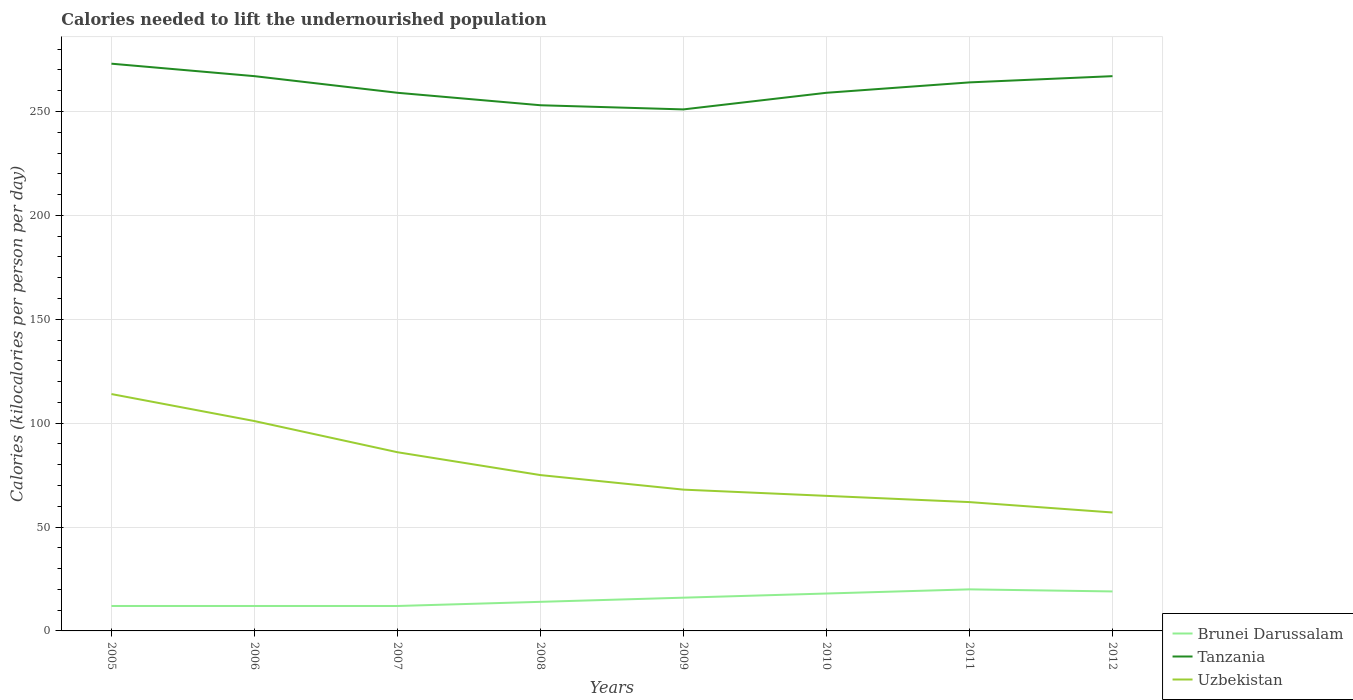How many different coloured lines are there?
Make the answer very short. 3. Across all years, what is the maximum total calories needed to lift the undernourished population in Uzbekistan?
Offer a terse response. 57. In which year was the total calories needed to lift the undernourished population in Uzbekistan maximum?
Your answer should be compact. 2012. What is the total total calories needed to lift the undernourished population in Brunei Darussalam in the graph?
Offer a terse response. -2. What is the difference between the highest and the second highest total calories needed to lift the undernourished population in Tanzania?
Provide a short and direct response. 22. What is the difference between the highest and the lowest total calories needed to lift the undernourished population in Brunei Darussalam?
Your response must be concise. 4. How many lines are there?
Your answer should be very brief. 3. How many years are there in the graph?
Give a very brief answer. 8. Does the graph contain any zero values?
Your answer should be very brief. No. Does the graph contain grids?
Your response must be concise. Yes. Where does the legend appear in the graph?
Keep it short and to the point. Bottom right. How many legend labels are there?
Your answer should be compact. 3. What is the title of the graph?
Your answer should be compact. Calories needed to lift the undernourished population. Does "South Asia" appear as one of the legend labels in the graph?
Ensure brevity in your answer.  No. What is the label or title of the Y-axis?
Give a very brief answer. Calories (kilocalories per person per day). What is the Calories (kilocalories per person per day) in Tanzania in 2005?
Your answer should be compact. 273. What is the Calories (kilocalories per person per day) of Uzbekistan in 2005?
Your response must be concise. 114. What is the Calories (kilocalories per person per day) of Brunei Darussalam in 2006?
Provide a succinct answer. 12. What is the Calories (kilocalories per person per day) of Tanzania in 2006?
Give a very brief answer. 267. What is the Calories (kilocalories per person per day) in Uzbekistan in 2006?
Give a very brief answer. 101. What is the Calories (kilocalories per person per day) in Tanzania in 2007?
Ensure brevity in your answer.  259. What is the Calories (kilocalories per person per day) of Uzbekistan in 2007?
Your answer should be very brief. 86. What is the Calories (kilocalories per person per day) of Tanzania in 2008?
Offer a very short reply. 253. What is the Calories (kilocalories per person per day) in Uzbekistan in 2008?
Give a very brief answer. 75. What is the Calories (kilocalories per person per day) of Tanzania in 2009?
Provide a short and direct response. 251. What is the Calories (kilocalories per person per day) in Uzbekistan in 2009?
Offer a terse response. 68. What is the Calories (kilocalories per person per day) of Brunei Darussalam in 2010?
Offer a terse response. 18. What is the Calories (kilocalories per person per day) in Tanzania in 2010?
Offer a very short reply. 259. What is the Calories (kilocalories per person per day) in Tanzania in 2011?
Offer a terse response. 264. What is the Calories (kilocalories per person per day) of Brunei Darussalam in 2012?
Your response must be concise. 19. What is the Calories (kilocalories per person per day) of Tanzania in 2012?
Your response must be concise. 267. What is the Calories (kilocalories per person per day) of Uzbekistan in 2012?
Your answer should be compact. 57. Across all years, what is the maximum Calories (kilocalories per person per day) of Tanzania?
Ensure brevity in your answer.  273. Across all years, what is the maximum Calories (kilocalories per person per day) of Uzbekistan?
Provide a succinct answer. 114. Across all years, what is the minimum Calories (kilocalories per person per day) of Tanzania?
Offer a very short reply. 251. Across all years, what is the minimum Calories (kilocalories per person per day) of Uzbekistan?
Your response must be concise. 57. What is the total Calories (kilocalories per person per day) in Brunei Darussalam in the graph?
Ensure brevity in your answer.  123. What is the total Calories (kilocalories per person per day) of Tanzania in the graph?
Give a very brief answer. 2093. What is the total Calories (kilocalories per person per day) of Uzbekistan in the graph?
Provide a succinct answer. 628. What is the difference between the Calories (kilocalories per person per day) of Brunei Darussalam in 2005 and that in 2006?
Keep it short and to the point. 0. What is the difference between the Calories (kilocalories per person per day) of Uzbekistan in 2005 and that in 2006?
Keep it short and to the point. 13. What is the difference between the Calories (kilocalories per person per day) in Tanzania in 2005 and that in 2007?
Provide a short and direct response. 14. What is the difference between the Calories (kilocalories per person per day) in Tanzania in 2005 and that in 2008?
Keep it short and to the point. 20. What is the difference between the Calories (kilocalories per person per day) of Uzbekistan in 2005 and that in 2008?
Offer a very short reply. 39. What is the difference between the Calories (kilocalories per person per day) of Tanzania in 2005 and that in 2009?
Offer a very short reply. 22. What is the difference between the Calories (kilocalories per person per day) in Uzbekistan in 2005 and that in 2009?
Ensure brevity in your answer.  46. What is the difference between the Calories (kilocalories per person per day) of Brunei Darussalam in 2005 and that in 2010?
Give a very brief answer. -6. What is the difference between the Calories (kilocalories per person per day) of Tanzania in 2005 and that in 2010?
Ensure brevity in your answer.  14. What is the difference between the Calories (kilocalories per person per day) in Tanzania in 2005 and that in 2011?
Make the answer very short. 9. What is the difference between the Calories (kilocalories per person per day) in Uzbekistan in 2005 and that in 2011?
Keep it short and to the point. 52. What is the difference between the Calories (kilocalories per person per day) of Brunei Darussalam in 2006 and that in 2007?
Your response must be concise. 0. What is the difference between the Calories (kilocalories per person per day) of Brunei Darussalam in 2006 and that in 2008?
Provide a succinct answer. -2. What is the difference between the Calories (kilocalories per person per day) in Uzbekistan in 2006 and that in 2008?
Your response must be concise. 26. What is the difference between the Calories (kilocalories per person per day) in Brunei Darussalam in 2006 and that in 2009?
Ensure brevity in your answer.  -4. What is the difference between the Calories (kilocalories per person per day) in Uzbekistan in 2006 and that in 2009?
Provide a short and direct response. 33. What is the difference between the Calories (kilocalories per person per day) of Tanzania in 2006 and that in 2010?
Offer a terse response. 8. What is the difference between the Calories (kilocalories per person per day) in Uzbekistan in 2006 and that in 2010?
Give a very brief answer. 36. What is the difference between the Calories (kilocalories per person per day) of Brunei Darussalam in 2006 and that in 2011?
Your answer should be compact. -8. What is the difference between the Calories (kilocalories per person per day) in Tanzania in 2006 and that in 2011?
Give a very brief answer. 3. What is the difference between the Calories (kilocalories per person per day) of Tanzania in 2006 and that in 2012?
Your response must be concise. 0. What is the difference between the Calories (kilocalories per person per day) in Brunei Darussalam in 2007 and that in 2008?
Offer a very short reply. -2. What is the difference between the Calories (kilocalories per person per day) in Tanzania in 2007 and that in 2008?
Your response must be concise. 6. What is the difference between the Calories (kilocalories per person per day) of Uzbekistan in 2007 and that in 2008?
Your answer should be very brief. 11. What is the difference between the Calories (kilocalories per person per day) of Brunei Darussalam in 2007 and that in 2009?
Offer a very short reply. -4. What is the difference between the Calories (kilocalories per person per day) in Brunei Darussalam in 2007 and that in 2010?
Give a very brief answer. -6. What is the difference between the Calories (kilocalories per person per day) in Tanzania in 2007 and that in 2010?
Make the answer very short. 0. What is the difference between the Calories (kilocalories per person per day) in Brunei Darussalam in 2007 and that in 2011?
Make the answer very short. -8. What is the difference between the Calories (kilocalories per person per day) in Uzbekistan in 2007 and that in 2011?
Provide a short and direct response. 24. What is the difference between the Calories (kilocalories per person per day) of Tanzania in 2007 and that in 2012?
Offer a very short reply. -8. What is the difference between the Calories (kilocalories per person per day) in Uzbekistan in 2007 and that in 2012?
Offer a very short reply. 29. What is the difference between the Calories (kilocalories per person per day) of Brunei Darussalam in 2008 and that in 2009?
Your response must be concise. -2. What is the difference between the Calories (kilocalories per person per day) in Brunei Darussalam in 2008 and that in 2010?
Ensure brevity in your answer.  -4. What is the difference between the Calories (kilocalories per person per day) in Uzbekistan in 2008 and that in 2011?
Give a very brief answer. 13. What is the difference between the Calories (kilocalories per person per day) in Brunei Darussalam in 2008 and that in 2012?
Your answer should be very brief. -5. What is the difference between the Calories (kilocalories per person per day) in Uzbekistan in 2008 and that in 2012?
Provide a succinct answer. 18. What is the difference between the Calories (kilocalories per person per day) of Brunei Darussalam in 2009 and that in 2011?
Give a very brief answer. -4. What is the difference between the Calories (kilocalories per person per day) of Tanzania in 2009 and that in 2011?
Provide a short and direct response. -13. What is the difference between the Calories (kilocalories per person per day) in Uzbekistan in 2009 and that in 2011?
Ensure brevity in your answer.  6. What is the difference between the Calories (kilocalories per person per day) in Tanzania in 2009 and that in 2012?
Keep it short and to the point. -16. What is the difference between the Calories (kilocalories per person per day) in Uzbekistan in 2009 and that in 2012?
Make the answer very short. 11. What is the difference between the Calories (kilocalories per person per day) in Tanzania in 2010 and that in 2011?
Your answer should be very brief. -5. What is the difference between the Calories (kilocalories per person per day) of Brunei Darussalam in 2010 and that in 2012?
Ensure brevity in your answer.  -1. What is the difference between the Calories (kilocalories per person per day) in Tanzania in 2010 and that in 2012?
Your response must be concise. -8. What is the difference between the Calories (kilocalories per person per day) in Uzbekistan in 2010 and that in 2012?
Keep it short and to the point. 8. What is the difference between the Calories (kilocalories per person per day) of Tanzania in 2011 and that in 2012?
Your response must be concise. -3. What is the difference between the Calories (kilocalories per person per day) of Brunei Darussalam in 2005 and the Calories (kilocalories per person per day) of Tanzania in 2006?
Keep it short and to the point. -255. What is the difference between the Calories (kilocalories per person per day) in Brunei Darussalam in 2005 and the Calories (kilocalories per person per day) in Uzbekistan in 2006?
Keep it short and to the point. -89. What is the difference between the Calories (kilocalories per person per day) of Tanzania in 2005 and the Calories (kilocalories per person per day) of Uzbekistan in 2006?
Your response must be concise. 172. What is the difference between the Calories (kilocalories per person per day) of Brunei Darussalam in 2005 and the Calories (kilocalories per person per day) of Tanzania in 2007?
Your response must be concise. -247. What is the difference between the Calories (kilocalories per person per day) in Brunei Darussalam in 2005 and the Calories (kilocalories per person per day) in Uzbekistan in 2007?
Provide a succinct answer. -74. What is the difference between the Calories (kilocalories per person per day) of Tanzania in 2005 and the Calories (kilocalories per person per day) of Uzbekistan in 2007?
Your answer should be very brief. 187. What is the difference between the Calories (kilocalories per person per day) of Brunei Darussalam in 2005 and the Calories (kilocalories per person per day) of Tanzania in 2008?
Your answer should be very brief. -241. What is the difference between the Calories (kilocalories per person per day) of Brunei Darussalam in 2005 and the Calories (kilocalories per person per day) of Uzbekistan in 2008?
Give a very brief answer. -63. What is the difference between the Calories (kilocalories per person per day) in Tanzania in 2005 and the Calories (kilocalories per person per day) in Uzbekistan in 2008?
Offer a terse response. 198. What is the difference between the Calories (kilocalories per person per day) in Brunei Darussalam in 2005 and the Calories (kilocalories per person per day) in Tanzania in 2009?
Make the answer very short. -239. What is the difference between the Calories (kilocalories per person per day) in Brunei Darussalam in 2005 and the Calories (kilocalories per person per day) in Uzbekistan in 2009?
Offer a terse response. -56. What is the difference between the Calories (kilocalories per person per day) in Tanzania in 2005 and the Calories (kilocalories per person per day) in Uzbekistan in 2009?
Provide a succinct answer. 205. What is the difference between the Calories (kilocalories per person per day) of Brunei Darussalam in 2005 and the Calories (kilocalories per person per day) of Tanzania in 2010?
Offer a terse response. -247. What is the difference between the Calories (kilocalories per person per day) in Brunei Darussalam in 2005 and the Calories (kilocalories per person per day) in Uzbekistan in 2010?
Offer a terse response. -53. What is the difference between the Calories (kilocalories per person per day) of Tanzania in 2005 and the Calories (kilocalories per person per day) of Uzbekistan in 2010?
Provide a succinct answer. 208. What is the difference between the Calories (kilocalories per person per day) in Brunei Darussalam in 2005 and the Calories (kilocalories per person per day) in Tanzania in 2011?
Your response must be concise. -252. What is the difference between the Calories (kilocalories per person per day) of Brunei Darussalam in 2005 and the Calories (kilocalories per person per day) of Uzbekistan in 2011?
Make the answer very short. -50. What is the difference between the Calories (kilocalories per person per day) in Tanzania in 2005 and the Calories (kilocalories per person per day) in Uzbekistan in 2011?
Your answer should be very brief. 211. What is the difference between the Calories (kilocalories per person per day) in Brunei Darussalam in 2005 and the Calories (kilocalories per person per day) in Tanzania in 2012?
Provide a short and direct response. -255. What is the difference between the Calories (kilocalories per person per day) in Brunei Darussalam in 2005 and the Calories (kilocalories per person per day) in Uzbekistan in 2012?
Ensure brevity in your answer.  -45. What is the difference between the Calories (kilocalories per person per day) in Tanzania in 2005 and the Calories (kilocalories per person per day) in Uzbekistan in 2012?
Make the answer very short. 216. What is the difference between the Calories (kilocalories per person per day) of Brunei Darussalam in 2006 and the Calories (kilocalories per person per day) of Tanzania in 2007?
Make the answer very short. -247. What is the difference between the Calories (kilocalories per person per day) in Brunei Darussalam in 2006 and the Calories (kilocalories per person per day) in Uzbekistan in 2007?
Your response must be concise. -74. What is the difference between the Calories (kilocalories per person per day) of Tanzania in 2006 and the Calories (kilocalories per person per day) of Uzbekistan in 2007?
Keep it short and to the point. 181. What is the difference between the Calories (kilocalories per person per day) in Brunei Darussalam in 2006 and the Calories (kilocalories per person per day) in Tanzania in 2008?
Your response must be concise. -241. What is the difference between the Calories (kilocalories per person per day) of Brunei Darussalam in 2006 and the Calories (kilocalories per person per day) of Uzbekistan in 2008?
Your response must be concise. -63. What is the difference between the Calories (kilocalories per person per day) in Tanzania in 2006 and the Calories (kilocalories per person per day) in Uzbekistan in 2008?
Provide a succinct answer. 192. What is the difference between the Calories (kilocalories per person per day) in Brunei Darussalam in 2006 and the Calories (kilocalories per person per day) in Tanzania in 2009?
Provide a short and direct response. -239. What is the difference between the Calories (kilocalories per person per day) in Brunei Darussalam in 2006 and the Calories (kilocalories per person per day) in Uzbekistan in 2009?
Offer a very short reply. -56. What is the difference between the Calories (kilocalories per person per day) of Tanzania in 2006 and the Calories (kilocalories per person per day) of Uzbekistan in 2009?
Your answer should be compact. 199. What is the difference between the Calories (kilocalories per person per day) of Brunei Darussalam in 2006 and the Calories (kilocalories per person per day) of Tanzania in 2010?
Your response must be concise. -247. What is the difference between the Calories (kilocalories per person per day) of Brunei Darussalam in 2006 and the Calories (kilocalories per person per day) of Uzbekistan in 2010?
Your answer should be compact. -53. What is the difference between the Calories (kilocalories per person per day) of Tanzania in 2006 and the Calories (kilocalories per person per day) of Uzbekistan in 2010?
Your answer should be compact. 202. What is the difference between the Calories (kilocalories per person per day) of Brunei Darussalam in 2006 and the Calories (kilocalories per person per day) of Tanzania in 2011?
Offer a very short reply. -252. What is the difference between the Calories (kilocalories per person per day) of Brunei Darussalam in 2006 and the Calories (kilocalories per person per day) of Uzbekistan in 2011?
Give a very brief answer. -50. What is the difference between the Calories (kilocalories per person per day) of Tanzania in 2006 and the Calories (kilocalories per person per day) of Uzbekistan in 2011?
Offer a very short reply. 205. What is the difference between the Calories (kilocalories per person per day) in Brunei Darussalam in 2006 and the Calories (kilocalories per person per day) in Tanzania in 2012?
Provide a short and direct response. -255. What is the difference between the Calories (kilocalories per person per day) of Brunei Darussalam in 2006 and the Calories (kilocalories per person per day) of Uzbekistan in 2012?
Make the answer very short. -45. What is the difference between the Calories (kilocalories per person per day) of Tanzania in 2006 and the Calories (kilocalories per person per day) of Uzbekistan in 2012?
Give a very brief answer. 210. What is the difference between the Calories (kilocalories per person per day) in Brunei Darussalam in 2007 and the Calories (kilocalories per person per day) in Tanzania in 2008?
Your response must be concise. -241. What is the difference between the Calories (kilocalories per person per day) in Brunei Darussalam in 2007 and the Calories (kilocalories per person per day) in Uzbekistan in 2008?
Your response must be concise. -63. What is the difference between the Calories (kilocalories per person per day) of Tanzania in 2007 and the Calories (kilocalories per person per day) of Uzbekistan in 2008?
Offer a very short reply. 184. What is the difference between the Calories (kilocalories per person per day) in Brunei Darussalam in 2007 and the Calories (kilocalories per person per day) in Tanzania in 2009?
Provide a short and direct response. -239. What is the difference between the Calories (kilocalories per person per day) of Brunei Darussalam in 2007 and the Calories (kilocalories per person per day) of Uzbekistan in 2009?
Your response must be concise. -56. What is the difference between the Calories (kilocalories per person per day) in Tanzania in 2007 and the Calories (kilocalories per person per day) in Uzbekistan in 2009?
Ensure brevity in your answer.  191. What is the difference between the Calories (kilocalories per person per day) of Brunei Darussalam in 2007 and the Calories (kilocalories per person per day) of Tanzania in 2010?
Offer a very short reply. -247. What is the difference between the Calories (kilocalories per person per day) of Brunei Darussalam in 2007 and the Calories (kilocalories per person per day) of Uzbekistan in 2010?
Your answer should be very brief. -53. What is the difference between the Calories (kilocalories per person per day) in Tanzania in 2007 and the Calories (kilocalories per person per day) in Uzbekistan in 2010?
Your answer should be compact. 194. What is the difference between the Calories (kilocalories per person per day) in Brunei Darussalam in 2007 and the Calories (kilocalories per person per day) in Tanzania in 2011?
Make the answer very short. -252. What is the difference between the Calories (kilocalories per person per day) of Brunei Darussalam in 2007 and the Calories (kilocalories per person per day) of Uzbekistan in 2011?
Give a very brief answer. -50. What is the difference between the Calories (kilocalories per person per day) of Tanzania in 2007 and the Calories (kilocalories per person per day) of Uzbekistan in 2011?
Offer a terse response. 197. What is the difference between the Calories (kilocalories per person per day) in Brunei Darussalam in 2007 and the Calories (kilocalories per person per day) in Tanzania in 2012?
Your answer should be very brief. -255. What is the difference between the Calories (kilocalories per person per day) of Brunei Darussalam in 2007 and the Calories (kilocalories per person per day) of Uzbekistan in 2012?
Your answer should be compact. -45. What is the difference between the Calories (kilocalories per person per day) of Tanzania in 2007 and the Calories (kilocalories per person per day) of Uzbekistan in 2012?
Provide a succinct answer. 202. What is the difference between the Calories (kilocalories per person per day) of Brunei Darussalam in 2008 and the Calories (kilocalories per person per day) of Tanzania in 2009?
Keep it short and to the point. -237. What is the difference between the Calories (kilocalories per person per day) of Brunei Darussalam in 2008 and the Calories (kilocalories per person per day) of Uzbekistan in 2009?
Make the answer very short. -54. What is the difference between the Calories (kilocalories per person per day) in Tanzania in 2008 and the Calories (kilocalories per person per day) in Uzbekistan in 2009?
Offer a very short reply. 185. What is the difference between the Calories (kilocalories per person per day) in Brunei Darussalam in 2008 and the Calories (kilocalories per person per day) in Tanzania in 2010?
Keep it short and to the point. -245. What is the difference between the Calories (kilocalories per person per day) of Brunei Darussalam in 2008 and the Calories (kilocalories per person per day) of Uzbekistan in 2010?
Provide a succinct answer. -51. What is the difference between the Calories (kilocalories per person per day) of Tanzania in 2008 and the Calories (kilocalories per person per day) of Uzbekistan in 2010?
Make the answer very short. 188. What is the difference between the Calories (kilocalories per person per day) of Brunei Darussalam in 2008 and the Calories (kilocalories per person per day) of Tanzania in 2011?
Provide a succinct answer. -250. What is the difference between the Calories (kilocalories per person per day) in Brunei Darussalam in 2008 and the Calories (kilocalories per person per day) in Uzbekistan in 2011?
Give a very brief answer. -48. What is the difference between the Calories (kilocalories per person per day) of Tanzania in 2008 and the Calories (kilocalories per person per day) of Uzbekistan in 2011?
Give a very brief answer. 191. What is the difference between the Calories (kilocalories per person per day) of Brunei Darussalam in 2008 and the Calories (kilocalories per person per day) of Tanzania in 2012?
Keep it short and to the point. -253. What is the difference between the Calories (kilocalories per person per day) in Brunei Darussalam in 2008 and the Calories (kilocalories per person per day) in Uzbekistan in 2012?
Your answer should be compact. -43. What is the difference between the Calories (kilocalories per person per day) of Tanzania in 2008 and the Calories (kilocalories per person per day) of Uzbekistan in 2012?
Provide a succinct answer. 196. What is the difference between the Calories (kilocalories per person per day) of Brunei Darussalam in 2009 and the Calories (kilocalories per person per day) of Tanzania in 2010?
Provide a succinct answer. -243. What is the difference between the Calories (kilocalories per person per day) in Brunei Darussalam in 2009 and the Calories (kilocalories per person per day) in Uzbekistan in 2010?
Offer a very short reply. -49. What is the difference between the Calories (kilocalories per person per day) in Tanzania in 2009 and the Calories (kilocalories per person per day) in Uzbekistan in 2010?
Provide a succinct answer. 186. What is the difference between the Calories (kilocalories per person per day) of Brunei Darussalam in 2009 and the Calories (kilocalories per person per day) of Tanzania in 2011?
Provide a succinct answer. -248. What is the difference between the Calories (kilocalories per person per day) in Brunei Darussalam in 2009 and the Calories (kilocalories per person per day) in Uzbekistan in 2011?
Offer a terse response. -46. What is the difference between the Calories (kilocalories per person per day) of Tanzania in 2009 and the Calories (kilocalories per person per day) of Uzbekistan in 2011?
Give a very brief answer. 189. What is the difference between the Calories (kilocalories per person per day) of Brunei Darussalam in 2009 and the Calories (kilocalories per person per day) of Tanzania in 2012?
Make the answer very short. -251. What is the difference between the Calories (kilocalories per person per day) of Brunei Darussalam in 2009 and the Calories (kilocalories per person per day) of Uzbekistan in 2012?
Offer a very short reply. -41. What is the difference between the Calories (kilocalories per person per day) of Tanzania in 2009 and the Calories (kilocalories per person per day) of Uzbekistan in 2012?
Keep it short and to the point. 194. What is the difference between the Calories (kilocalories per person per day) of Brunei Darussalam in 2010 and the Calories (kilocalories per person per day) of Tanzania in 2011?
Your answer should be compact. -246. What is the difference between the Calories (kilocalories per person per day) in Brunei Darussalam in 2010 and the Calories (kilocalories per person per day) in Uzbekistan in 2011?
Offer a very short reply. -44. What is the difference between the Calories (kilocalories per person per day) of Tanzania in 2010 and the Calories (kilocalories per person per day) of Uzbekistan in 2011?
Provide a short and direct response. 197. What is the difference between the Calories (kilocalories per person per day) in Brunei Darussalam in 2010 and the Calories (kilocalories per person per day) in Tanzania in 2012?
Make the answer very short. -249. What is the difference between the Calories (kilocalories per person per day) of Brunei Darussalam in 2010 and the Calories (kilocalories per person per day) of Uzbekistan in 2012?
Provide a short and direct response. -39. What is the difference between the Calories (kilocalories per person per day) in Tanzania in 2010 and the Calories (kilocalories per person per day) in Uzbekistan in 2012?
Your answer should be very brief. 202. What is the difference between the Calories (kilocalories per person per day) in Brunei Darussalam in 2011 and the Calories (kilocalories per person per day) in Tanzania in 2012?
Your response must be concise. -247. What is the difference between the Calories (kilocalories per person per day) in Brunei Darussalam in 2011 and the Calories (kilocalories per person per day) in Uzbekistan in 2012?
Make the answer very short. -37. What is the difference between the Calories (kilocalories per person per day) in Tanzania in 2011 and the Calories (kilocalories per person per day) in Uzbekistan in 2012?
Your answer should be compact. 207. What is the average Calories (kilocalories per person per day) in Brunei Darussalam per year?
Provide a short and direct response. 15.38. What is the average Calories (kilocalories per person per day) in Tanzania per year?
Offer a very short reply. 261.62. What is the average Calories (kilocalories per person per day) in Uzbekistan per year?
Your answer should be very brief. 78.5. In the year 2005, what is the difference between the Calories (kilocalories per person per day) in Brunei Darussalam and Calories (kilocalories per person per day) in Tanzania?
Give a very brief answer. -261. In the year 2005, what is the difference between the Calories (kilocalories per person per day) in Brunei Darussalam and Calories (kilocalories per person per day) in Uzbekistan?
Provide a succinct answer. -102. In the year 2005, what is the difference between the Calories (kilocalories per person per day) of Tanzania and Calories (kilocalories per person per day) of Uzbekistan?
Your response must be concise. 159. In the year 2006, what is the difference between the Calories (kilocalories per person per day) of Brunei Darussalam and Calories (kilocalories per person per day) of Tanzania?
Keep it short and to the point. -255. In the year 2006, what is the difference between the Calories (kilocalories per person per day) of Brunei Darussalam and Calories (kilocalories per person per day) of Uzbekistan?
Ensure brevity in your answer.  -89. In the year 2006, what is the difference between the Calories (kilocalories per person per day) in Tanzania and Calories (kilocalories per person per day) in Uzbekistan?
Provide a succinct answer. 166. In the year 2007, what is the difference between the Calories (kilocalories per person per day) in Brunei Darussalam and Calories (kilocalories per person per day) in Tanzania?
Make the answer very short. -247. In the year 2007, what is the difference between the Calories (kilocalories per person per day) in Brunei Darussalam and Calories (kilocalories per person per day) in Uzbekistan?
Make the answer very short. -74. In the year 2007, what is the difference between the Calories (kilocalories per person per day) in Tanzania and Calories (kilocalories per person per day) in Uzbekistan?
Your answer should be very brief. 173. In the year 2008, what is the difference between the Calories (kilocalories per person per day) of Brunei Darussalam and Calories (kilocalories per person per day) of Tanzania?
Give a very brief answer. -239. In the year 2008, what is the difference between the Calories (kilocalories per person per day) in Brunei Darussalam and Calories (kilocalories per person per day) in Uzbekistan?
Provide a succinct answer. -61. In the year 2008, what is the difference between the Calories (kilocalories per person per day) in Tanzania and Calories (kilocalories per person per day) in Uzbekistan?
Provide a short and direct response. 178. In the year 2009, what is the difference between the Calories (kilocalories per person per day) in Brunei Darussalam and Calories (kilocalories per person per day) in Tanzania?
Your answer should be very brief. -235. In the year 2009, what is the difference between the Calories (kilocalories per person per day) in Brunei Darussalam and Calories (kilocalories per person per day) in Uzbekistan?
Your response must be concise. -52. In the year 2009, what is the difference between the Calories (kilocalories per person per day) of Tanzania and Calories (kilocalories per person per day) of Uzbekistan?
Your answer should be very brief. 183. In the year 2010, what is the difference between the Calories (kilocalories per person per day) of Brunei Darussalam and Calories (kilocalories per person per day) of Tanzania?
Ensure brevity in your answer.  -241. In the year 2010, what is the difference between the Calories (kilocalories per person per day) of Brunei Darussalam and Calories (kilocalories per person per day) of Uzbekistan?
Provide a short and direct response. -47. In the year 2010, what is the difference between the Calories (kilocalories per person per day) in Tanzania and Calories (kilocalories per person per day) in Uzbekistan?
Ensure brevity in your answer.  194. In the year 2011, what is the difference between the Calories (kilocalories per person per day) in Brunei Darussalam and Calories (kilocalories per person per day) in Tanzania?
Your answer should be very brief. -244. In the year 2011, what is the difference between the Calories (kilocalories per person per day) of Brunei Darussalam and Calories (kilocalories per person per day) of Uzbekistan?
Your answer should be compact. -42. In the year 2011, what is the difference between the Calories (kilocalories per person per day) of Tanzania and Calories (kilocalories per person per day) of Uzbekistan?
Ensure brevity in your answer.  202. In the year 2012, what is the difference between the Calories (kilocalories per person per day) of Brunei Darussalam and Calories (kilocalories per person per day) of Tanzania?
Make the answer very short. -248. In the year 2012, what is the difference between the Calories (kilocalories per person per day) in Brunei Darussalam and Calories (kilocalories per person per day) in Uzbekistan?
Ensure brevity in your answer.  -38. In the year 2012, what is the difference between the Calories (kilocalories per person per day) of Tanzania and Calories (kilocalories per person per day) of Uzbekistan?
Give a very brief answer. 210. What is the ratio of the Calories (kilocalories per person per day) of Brunei Darussalam in 2005 to that in 2006?
Make the answer very short. 1. What is the ratio of the Calories (kilocalories per person per day) in Tanzania in 2005 to that in 2006?
Keep it short and to the point. 1.02. What is the ratio of the Calories (kilocalories per person per day) in Uzbekistan in 2005 to that in 2006?
Ensure brevity in your answer.  1.13. What is the ratio of the Calories (kilocalories per person per day) of Brunei Darussalam in 2005 to that in 2007?
Keep it short and to the point. 1. What is the ratio of the Calories (kilocalories per person per day) in Tanzania in 2005 to that in 2007?
Your response must be concise. 1.05. What is the ratio of the Calories (kilocalories per person per day) of Uzbekistan in 2005 to that in 2007?
Provide a short and direct response. 1.33. What is the ratio of the Calories (kilocalories per person per day) in Brunei Darussalam in 2005 to that in 2008?
Provide a succinct answer. 0.86. What is the ratio of the Calories (kilocalories per person per day) in Tanzania in 2005 to that in 2008?
Offer a terse response. 1.08. What is the ratio of the Calories (kilocalories per person per day) in Uzbekistan in 2005 to that in 2008?
Offer a very short reply. 1.52. What is the ratio of the Calories (kilocalories per person per day) in Brunei Darussalam in 2005 to that in 2009?
Provide a succinct answer. 0.75. What is the ratio of the Calories (kilocalories per person per day) of Tanzania in 2005 to that in 2009?
Give a very brief answer. 1.09. What is the ratio of the Calories (kilocalories per person per day) in Uzbekistan in 2005 to that in 2009?
Keep it short and to the point. 1.68. What is the ratio of the Calories (kilocalories per person per day) in Tanzania in 2005 to that in 2010?
Give a very brief answer. 1.05. What is the ratio of the Calories (kilocalories per person per day) of Uzbekistan in 2005 to that in 2010?
Offer a very short reply. 1.75. What is the ratio of the Calories (kilocalories per person per day) of Tanzania in 2005 to that in 2011?
Give a very brief answer. 1.03. What is the ratio of the Calories (kilocalories per person per day) in Uzbekistan in 2005 to that in 2011?
Offer a terse response. 1.84. What is the ratio of the Calories (kilocalories per person per day) of Brunei Darussalam in 2005 to that in 2012?
Your answer should be very brief. 0.63. What is the ratio of the Calories (kilocalories per person per day) in Tanzania in 2005 to that in 2012?
Make the answer very short. 1.02. What is the ratio of the Calories (kilocalories per person per day) in Tanzania in 2006 to that in 2007?
Offer a very short reply. 1.03. What is the ratio of the Calories (kilocalories per person per day) of Uzbekistan in 2006 to that in 2007?
Provide a short and direct response. 1.17. What is the ratio of the Calories (kilocalories per person per day) in Brunei Darussalam in 2006 to that in 2008?
Your answer should be compact. 0.86. What is the ratio of the Calories (kilocalories per person per day) of Tanzania in 2006 to that in 2008?
Offer a very short reply. 1.06. What is the ratio of the Calories (kilocalories per person per day) in Uzbekistan in 2006 to that in 2008?
Make the answer very short. 1.35. What is the ratio of the Calories (kilocalories per person per day) in Tanzania in 2006 to that in 2009?
Your answer should be very brief. 1.06. What is the ratio of the Calories (kilocalories per person per day) of Uzbekistan in 2006 to that in 2009?
Ensure brevity in your answer.  1.49. What is the ratio of the Calories (kilocalories per person per day) of Tanzania in 2006 to that in 2010?
Your answer should be very brief. 1.03. What is the ratio of the Calories (kilocalories per person per day) in Uzbekistan in 2006 to that in 2010?
Provide a short and direct response. 1.55. What is the ratio of the Calories (kilocalories per person per day) of Tanzania in 2006 to that in 2011?
Offer a very short reply. 1.01. What is the ratio of the Calories (kilocalories per person per day) in Uzbekistan in 2006 to that in 2011?
Keep it short and to the point. 1.63. What is the ratio of the Calories (kilocalories per person per day) of Brunei Darussalam in 2006 to that in 2012?
Keep it short and to the point. 0.63. What is the ratio of the Calories (kilocalories per person per day) in Uzbekistan in 2006 to that in 2012?
Your answer should be compact. 1.77. What is the ratio of the Calories (kilocalories per person per day) of Tanzania in 2007 to that in 2008?
Offer a terse response. 1.02. What is the ratio of the Calories (kilocalories per person per day) in Uzbekistan in 2007 to that in 2008?
Your response must be concise. 1.15. What is the ratio of the Calories (kilocalories per person per day) in Brunei Darussalam in 2007 to that in 2009?
Offer a terse response. 0.75. What is the ratio of the Calories (kilocalories per person per day) of Tanzania in 2007 to that in 2009?
Give a very brief answer. 1.03. What is the ratio of the Calories (kilocalories per person per day) of Uzbekistan in 2007 to that in 2009?
Give a very brief answer. 1.26. What is the ratio of the Calories (kilocalories per person per day) of Tanzania in 2007 to that in 2010?
Ensure brevity in your answer.  1. What is the ratio of the Calories (kilocalories per person per day) of Uzbekistan in 2007 to that in 2010?
Make the answer very short. 1.32. What is the ratio of the Calories (kilocalories per person per day) of Tanzania in 2007 to that in 2011?
Your answer should be compact. 0.98. What is the ratio of the Calories (kilocalories per person per day) of Uzbekistan in 2007 to that in 2011?
Your response must be concise. 1.39. What is the ratio of the Calories (kilocalories per person per day) in Brunei Darussalam in 2007 to that in 2012?
Give a very brief answer. 0.63. What is the ratio of the Calories (kilocalories per person per day) in Tanzania in 2007 to that in 2012?
Keep it short and to the point. 0.97. What is the ratio of the Calories (kilocalories per person per day) of Uzbekistan in 2007 to that in 2012?
Your answer should be compact. 1.51. What is the ratio of the Calories (kilocalories per person per day) of Tanzania in 2008 to that in 2009?
Ensure brevity in your answer.  1.01. What is the ratio of the Calories (kilocalories per person per day) in Uzbekistan in 2008 to that in 2009?
Provide a succinct answer. 1.1. What is the ratio of the Calories (kilocalories per person per day) in Brunei Darussalam in 2008 to that in 2010?
Give a very brief answer. 0.78. What is the ratio of the Calories (kilocalories per person per day) of Tanzania in 2008 to that in 2010?
Ensure brevity in your answer.  0.98. What is the ratio of the Calories (kilocalories per person per day) in Uzbekistan in 2008 to that in 2010?
Your answer should be compact. 1.15. What is the ratio of the Calories (kilocalories per person per day) of Brunei Darussalam in 2008 to that in 2011?
Give a very brief answer. 0.7. What is the ratio of the Calories (kilocalories per person per day) of Tanzania in 2008 to that in 2011?
Your answer should be very brief. 0.96. What is the ratio of the Calories (kilocalories per person per day) in Uzbekistan in 2008 to that in 2011?
Provide a succinct answer. 1.21. What is the ratio of the Calories (kilocalories per person per day) of Brunei Darussalam in 2008 to that in 2012?
Your response must be concise. 0.74. What is the ratio of the Calories (kilocalories per person per day) in Tanzania in 2008 to that in 2012?
Give a very brief answer. 0.95. What is the ratio of the Calories (kilocalories per person per day) in Uzbekistan in 2008 to that in 2012?
Your answer should be very brief. 1.32. What is the ratio of the Calories (kilocalories per person per day) in Brunei Darussalam in 2009 to that in 2010?
Ensure brevity in your answer.  0.89. What is the ratio of the Calories (kilocalories per person per day) of Tanzania in 2009 to that in 2010?
Ensure brevity in your answer.  0.97. What is the ratio of the Calories (kilocalories per person per day) in Uzbekistan in 2009 to that in 2010?
Your response must be concise. 1.05. What is the ratio of the Calories (kilocalories per person per day) in Brunei Darussalam in 2009 to that in 2011?
Offer a very short reply. 0.8. What is the ratio of the Calories (kilocalories per person per day) of Tanzania in 2009 to that in 2011?
Provide a short and direct response. 0.95. What is the ratio of the Calories (kilocalories per person per day) in Uzbekistan in 2009 to that in 2011?
Keep it short and to the point. 1.1. What is the ratio of the Calories (kilocalories per person per day) in Brunei Darussalam in 2009 to that in 2012?
Offer a terse response. 0.84. What is the ratio of the Calories (kilocalories per person per day) in Tanzania in 2009 to that in 2012?
Offer a terse response. 0.94. What is the ratio of the Calories (kilocalories per person per day) in Uzbekistan in 2009 to that in 2012?
Offer a terse response. 1.19. What is the ratio of the Calories (kilocalories per person per day) of Tanzania in 2010 to that in 2011?
Ensure brevity in your answer.  0.98. What is the ratio of the Calories (kilocalories per person per day) of Uzbekistan in 2010 to that in 2011?
Your answer should be very brief. 1.05. What is the ratio of the Calories (kilocalories per person per day) in Brunei Darussalam in 2010 to that in 2012?
Your answer should be very brief. 0.95. What is the ratio of the Calories (kilocalories per person per day) of Uzbekistan in 2010 to that in 2012?
Your response must be concise. 1.14. What is the ratio of the Calories (kilocalories per person per day) in Brunei Darussalam in 2011 to that in 2012?
Offer a terse response. 1.05. What is the ratio of the Calories (kilocalories per person per day) in Uzbekistan in 2011 to that in 2012?
Provide a short and direct response. 1.09. What is the difference between the highest and the second highest Calories (kilocalories per person per day) of Brunei Darussalam?
Keep it short and to the point. 1. What is the difference between the highest and the second highest Calories (kilocalories per person per day) in Tanzania?
Your response must be concise. 6. What is the difference between the highest and the lowest Calories (kilocalories per person per day) in Brunei Darussalam?
Provide a succinct answer. 8. What is the difference between the highest and the lowest Calories (kilocalories per person per day) of Uzbekistan?
Offer a terse response. 57. 